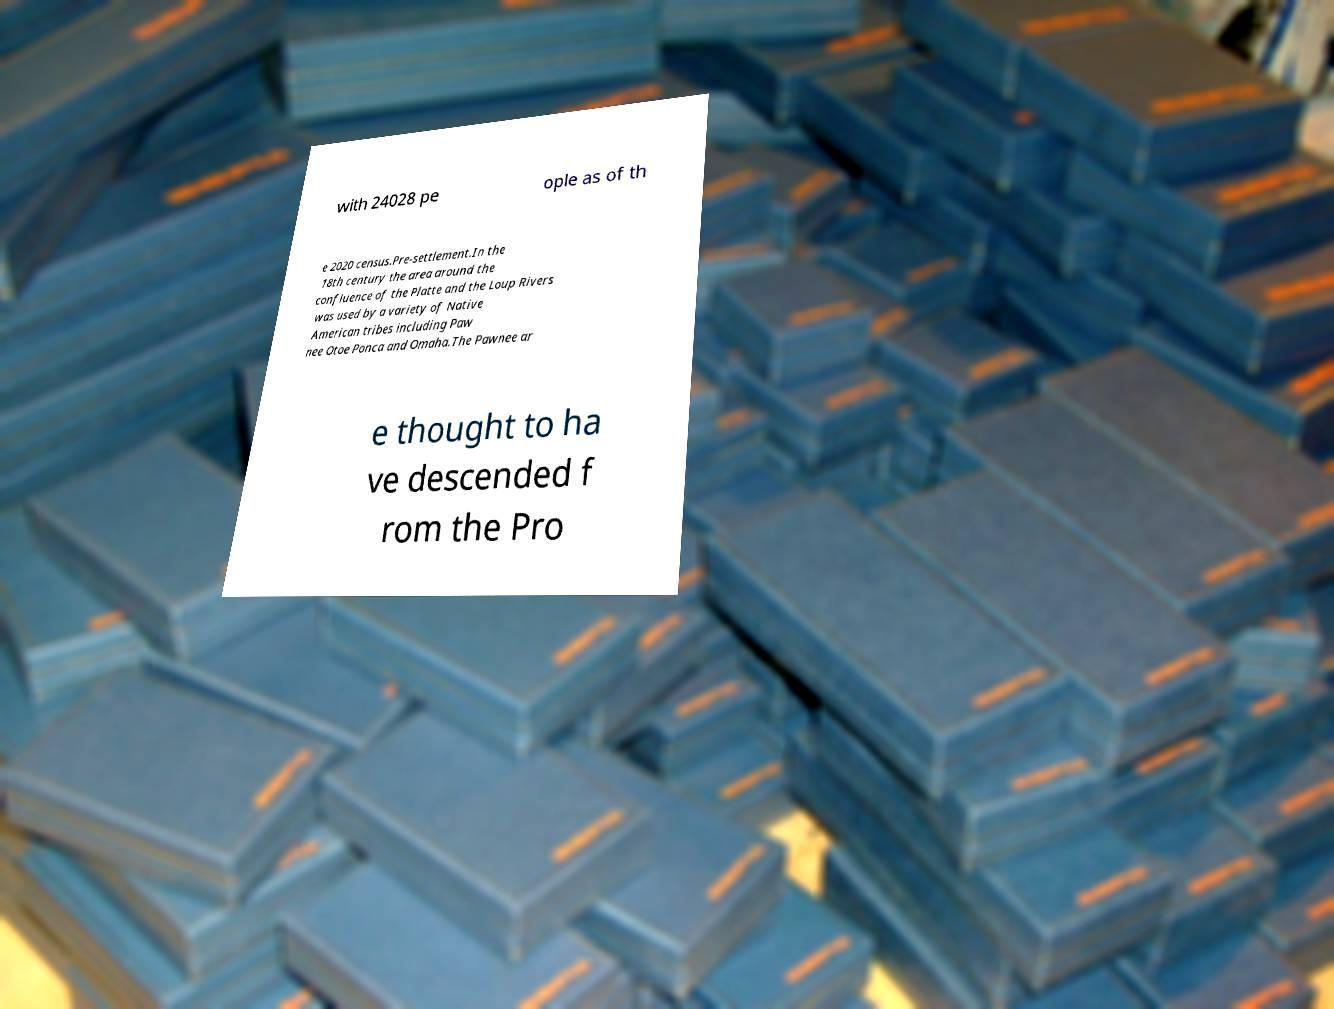Please identify and transcribe the text found in this image. with 24028 pe ople as of th e 2020 census.Pre-settlement.In the 18th century the area around the confluence of the Platte and the Loup Rivers was used by a variety of Native American tribes including Paw nee Otoe Ponca and Omaha.The Pawnee ar e thought to ha ve descended f rom the Pro 